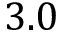Convert formula to latex. <formula><loc_0><loc_0><loc_500><loc_500>3 . 0</formula> 